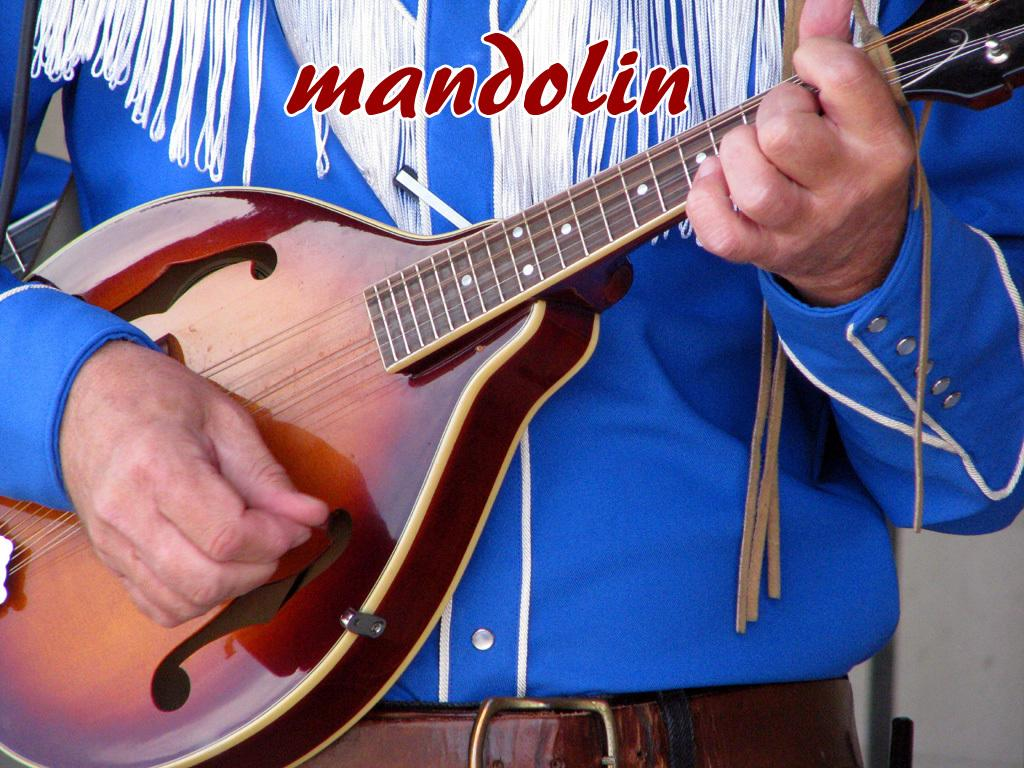What is the person in the image doing? The person is holding a musical instrument in the image. Can you describe the person's clothing? The person is wearing a dress with blue, white, and brown colors. What color is the background of the image? The background of the image is white. What type of curtain can be seen hanging from the dock in the image? There is no curtain or dock present in the image. How many eggs are visible on the person's dress in the image? There are no eggs visible on the person's dress in the image. 